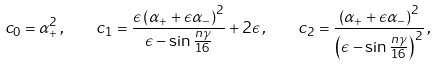<formula> <loc_0><loc_0><loc_500><loc_500>c _ { 0 } = \alpha ^ { 2 } _ { + } \, , \quad c _ { 1 } = \frac { \epsilon \left ( \alpha _ { + } + \epsilon \alpha _ { - } \right ) ^ { 2 } } { \epsilon - \sin \frac { n \gamma } { 1 6 } } + 2 \epsilon \, , \quad c _ { 2 } = \frac { \left ( \alpha _ { + } + \epsilon \alpha _ { - } \right ) ^ { 2 } } { \left ( \epsilon - \sin \frac { n \gamma } { 1 6 } \right ) ^ { 2 } } \, ,</formula> 